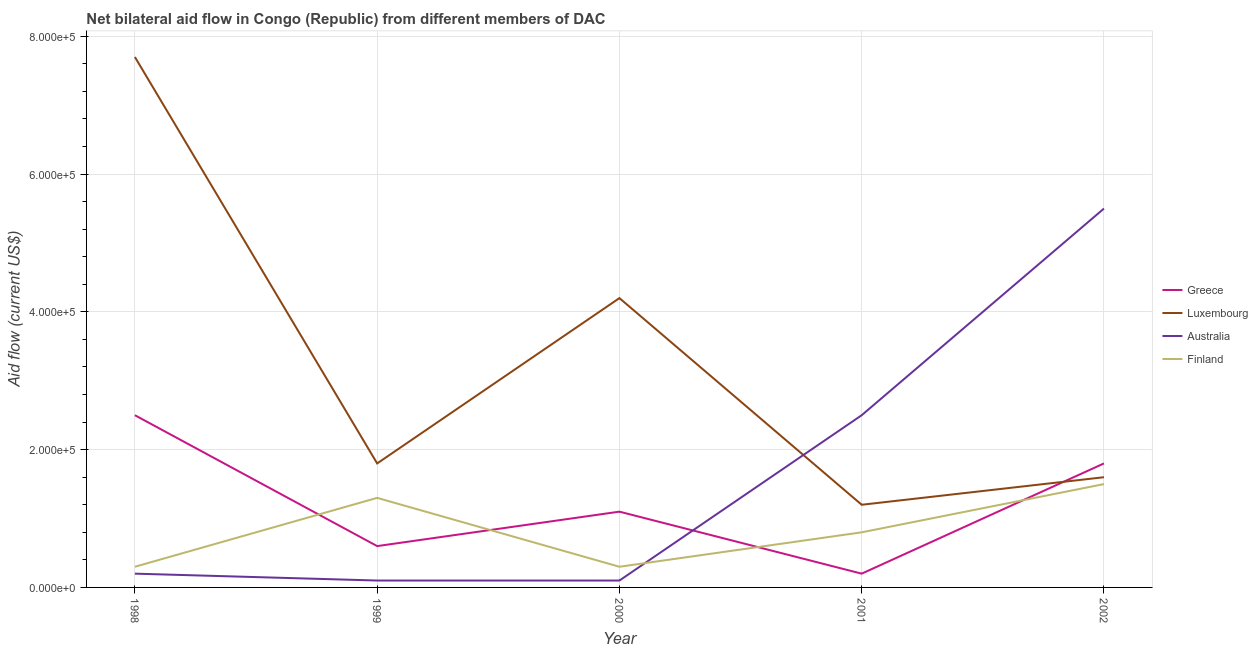Is the number of lines equal to the number of legend labels?
Ensure brevity in your answer.  Yes. What is the amount of aid given by australia in 2001?
Your answer should be compact. 2.50e+05. Across all years, what is the maximum amount of aid given by luxembourg?
Offer a very short reply. 7.70e+05. Across all years, what is the minimum amount of aid given by greece?
Provide a succinct answer. 2.00e+04. In which year was the amount of aid given by finland minimum?
Offer a very short reply. 1998. What is the total amount of aid given by luxembourg in the graph?
Keep it short and to the point. 1.65e+06. What is the difference between the amount of aid given by greece in 2000 and that in 2001?
Your response must be concise. 9.00e+04. What is the difference between the amount of aid given by luxembourg in 2001 and the amount of aid given by greece in 1999?
Offer a terse response. 6.00e+04. What is the average amount of aid given by australia per year?
Make the answer very short. 1.68e+05. In the year 2000, what is the difference between the amount of aid given by luxembourg and amount of aid given by australia?
Your answer should be compact. 4.10e+05. In how many years, is the amount of aid given by australia greater than 440000 US$?
Provide a succinct answer. 1. What is the ratio of the amount of aid given by australia in 1999 to that in 2001?
Your answer should be compact. 0.04. Is the amount of aid given by australia in 1999 less than that in 2002?
Your response must be concise. Yes. Is the difference between the amount of aid given by finland in 1999 and 2001 greater than the difference between the amount of aid given by luxembourg in 1999 and 2001?
Give a very brief answer. No. What is the difference between the highest and the second highest amount of aid given by luxembourg?
Your response must be concise. 3.50e+05. What is the difference between the highest and the lowest amount of aid given by australia?
Your response must be concise. 5.40e+05. In how many years, is the amount of aid given by australia greater than the average amount of aid given by australia taken over all years?
Keep it short and to the point. 2. Is it the case that in every year, the sum of the amount of aid given by greece and amount of aid given by luxembourg is greater than the amount of aid given by australia?
Keep it short and to the point. No. Does the amount of aid given by australia monotonically increase over the years?
Your response must be concise. No. Is the amount of aid given by greece strictly less than the amount of aid given by luxembourg over the years?
Ensure brevity in your answer.  No. What is the difference between two consecutive major ticks on the Y-axis?
Your answer should be compact. 2.00e+05. Does the graph contain any zero values?
Give a very brief answer. No. Does the graph contain grids?
Your answer should be compact. Yes. How are the legend labels stacked?
Ensure brevity in your answer.  Vertical. What is the title of the graph?
Offer a very short reply. Net bilateral aid flow in Congo (Republic) from different members of DAC. What is the label or title of the Y-axis?
Offer a terse response. Aid flow (current US$). What is the Aid flow (current US$) in Greece in 1998?
Your answer should be compact. 2.50e+05. What is the Aid flow (current US$) of Luxembourg in 1998?
Ensure brevity in your answer.  7.70e+05. What is the Aid flow (current US$) of Australia in 1998?
Provide a short and direct response. 2.00e+04. What is the Aid flow (current US$) of Finland in 1998?
Give a very brief answer. 3.00e+04. What is the Aid flow (current US$) of Greece in 1999?
Your response must be concise. 6.00e+04. What is the Aid flow (current US$) of Luxembourg in 1999?
Your response must be concise. 1.80e+05. What is the Aid flow (current US$) of Australia in 1999?
Offer a terse response. 10000. What is the Aid flow (current US$) of Greece in 2000?
Keep it short and to the point. 1.10e+05. What is the Aid flow (current US$) of Australia in 2000?
Your answer should be compact. 10000. What is the Aid flow (current US$) of Luxembourg in 2001?
Offer a terse response. 1.20e+05. What is the Aid flow (current US$) of Greece in 2002?
Make the answer very short. 1.80e+05. What is the Aid flow (current US$) of Luxembourg in 2002?
Provide a short and direct response. 1.60e+05. What is the Aid flow (current US$) of Australia in 2002?
Offer a terse response. 5.50e+05. What is the Aid flow (current US$) of Finland in 2002?
Your answer should be compact. 1.50e+05. Across all years, what is the maximum Aid flow (current US$) of Greece?
Your answer should be compact. 2.50e+05. Across all years, what is the maximum Aid flow (current US$) of Luxembourg?
Offer a terse response. 7.70e+05. Across all years, what is the maximum Aid flow (current US$) in Finland?
Make the answer very short. 1.50e+05. Across all years, what is the minimum Aid flow (current US$) of Greece?
Keep it short and to the point. 2.00e+04. Across all years, what is the minimum Aid flow (current US$) of Luxembourg?
Keep it short and to the point. 1.20e+05. What is the total Aid flow (current US$) of Greece in the graph?
Offer a very short reply. 6.20e+05. What is the total Aid flow (current US$) in Luxembourg in the graph?
Ensure brevity in your answer.  1.65e+06. What is the total Aid flow (current US$) in Australia in the graph?
Your answer should be very brief. 8.40e+05. What is the total Aid flow (current US$) of Finland in the graph?
Your answer should be very brief. 4.20e+05. What is the difference between the Aid flow (current US$) of Greece in 1998 and that in 1999?
Your answer should be compact. 1.90e+05. What is the difference between the Aid flow (current US$) of Luxembourg in 1998 and that in 1999?
Offer a terse response. 5.90e+05. What is the difference between the Aid flow (current US$) in Australia in 1998 and that in 1999?
Provide a short and direct response. 10000. What is the difference between the Aid flow (current US$) in Greece in 1998 and that in 2000?
Ensure brevity in your answer.  1.40e+05. What is the difference between the Aid flow (current US$) of Luxembourg in 1998 and that in 2000?
Provide a short and direct response. 3.50e+05. What is the difference between the Aid flow (current US$) in Australia in 1998 and that in 2000?
Make the answer very short. 10000. What is the difference between the Aid flow (current US$) of Greece in 1998 and that in 2001?
Ensure brevity in your answer.  2.30e+05. What is the difference between the Aid flow (current US$) of Luxembourg in 1998 and that in 2001?
Your answer should be very brief. 6.50e+05. What is the difference between the Aid flow (current US$) of Australia in 1998 and that in 2001?
Offer a terse response. -2.30e+05. What is the difference between the Aid flow (current US$) in Finland in 1998 and that in 2001?
Ensure brevity in your answer.  -5.00e+04. What is the difference between the Aid flow (current US$) in Luxembourg in 1998 and that in 2002?
Offer a terse response. 6.10e+05. What is the difference between the Aid flow (current US$) of Australia in 1998 and that in 2002?
Your answer should be very brief. -5.30e+05. What is the difference between the Aid flow (current US$) in Finland in 1998 and that in 2002?
Provide a short and direct response. -1.20e+05. What is the difference between the Aid flow (current US$) of Australia in 1999 and that in 2000?
Make the answer very short. 0. What is the difference between the Aid flow (current US$) in Australia in 1999 and that in 2001?
Make the answer very short. -2.40e+05. What is the difference between the Aid flow (current US$) of Finland in 1999 and that in 2001?
Your response must be concise. 5.00e+04. What is the difference between the Aid flow (current US$) in Australia in 1999 and that in 2002?
Your answer should be very brief. -5.40e+05. What is the difference between the Aid flow (current US$) in Finland in 1999 and that in 2002?
Your answer should be very brief. -2.00e+04. What is the difference between the Aid flow (current US$) of Finland in 2000 and that in 2001?
Your answer should be very brief. -5.00e+04. What is the difference between the Aid flow (current US$) of Greece in 2000 and that in 2002?
Give a very brief answer. -7.00e+04. What is the difference between the Aid flow (current US$) of Australia in 2000 and that in 2002?
Keep it short and to the point. -5.40e+05. What is the difference between the Aid flow (current US$) in Finland in 2000 and that in 2002?
Keep it short and to the point. -1.20e+05. What is the difference between the Aid flow (current US$) of Greece in 1998 and the Aid flow (current US$) of Finland in 1999?
Offer a terse response. 1.20e+05. What is the difference between the Aid flow (current US$) of Luxembourg in 1998 and the Aid flow (current US$) of Australia in 1999?
Your response must be concise. 7.60e+05. What is the difference between the Aid flow (current US$) in Luxembourg in 1998 and the Aid flow (current US$) in Finland in 1999?
Give a very brief answer. 6.40e+05. What is the difference between the Aid flow (current US$) of Greece in 1998 and the Aid flow (current US$) of Finland in 2000?
Make the answer very short. 2.20e+05. What is the difference between the Aid flow (current US$) of Luxembourg in 1998 and the Aid flow (current US$) of Australia in 2000?
Offer a very short reply. 7.60e+05. What is the difference between the Aid flow (current US$) of Luxembourg in 1998 and the Aid flow (current US$) of Finland in 2000?
Keep it short and to the point. 7.40e+05. What is the difference between the Aid flow (current US$) in Greece in 1998 and the Aid flow (current US$) in Finland in 2001?
Your answer should be compact. 1.70e+05. What is the difference between the Aid flow (current US$) of Luxembourg in 1998 and the Aid flow (current US$) of Australia in 2001?
Make the answer very short. 5.20e+05. What is the difference between the Aid flow (current US$) in Luxembourg in 1998 and the Aid flow (current US$) in Finland in 2001?
Provide a succinct answer. 6.90e+05. What is the difference between the Aid flow (current US$) of Greece in 1998 and the Aid flow (current US$) of Luxembourg in 2002?
Make the answer very short. 9.00e+04. What is the difference between the Aid flow (current US$) in Luxembourg in 1998 and the Aid flow (current US$) in Finland in 2002?
Provide a succinct answer. 6.20e+05. What is the difference between the Aid flow (current US$) of Greece in 1999 and the Aid flow (current US$) of Luxembourg in 2000?
Your response must be concise. -3.60e+05. What is the difference between the Aid flow (current US$) in Greece in 1999 and the Aid flow (current US$) in Australia in 2000?
Provide a short and direct response. 5.00e+04. What is the difference between the Aid flow (current US$) in Greece in 1999 and the Aid flow (current US$) in Finland in 2000?
Your response must be concise. 3.00e+04. What is the difference between the Aid flow (current US$) in Luxembourg in 1999 and the Aid flow (current US$) in Australia in 2000?
Ensure brevity in your answer.  1.70e+05. What is the difference between the Aid flow (current US$) of Greece in 1999 and the Aid flow (current US$) of Luxembourg in 2001?
Provide a short and direct response. -6.00e+04. What is the difference between the Aid flow (current US$) of Greece in 1999 and the Aid flow (current US$) of Australia in 2001?
Your response must be concise. -1.90e+05. What is the difference between the Aid flow (current US$) in Luxembourg in 1999 and the Aid flow (current US$) in Finland in 2001?
Provide a succinct answer. 1.00e+05. What is the difference between the Aid flow (current US$) in Australia in 1999 and the Aid flow (current US$) in Finland in 2001?
Make the answer very short. -7.00e+04. What is the difference between the Aid flow (current US$) in Greece in 1999 and the Aid flow (current US$) in Luxembourg in 2002?
Ensure brevity in your answer.  -1.00e+05. What is the difference between the Aid flow (current US$) in Greece in 1999 and the Aid flow (current US$) in Australia in 2002?
Provide a short and direct response. -4.90e+05. What is the difference between the Aid flow (current US$) of Greece in 1999 and the Aid flow (current US$) of Finland in 2002?
Your answer should be very brief. -9.00e+04. What is the difference between the Aid flow (current US$) of Luxembourg in 1999 and the Aid flow (current US$) of Australia in 2002?
Ensure brevity in your answer.  -3.70e+05. What is the difference between the Aid flow (current US$) in Luxembourg in 1999 and the Aid flow (current US$) in Finland in 2002?
Your answer should be very brief. 3.00e+04. What is the difference between the Aid flow (current US$) of Greece in 2000 and the Aid flow (current US$) of Australia in 2001?
Provide a short and direct response. -1.40e+05. What is the difference between the Aid flow (current US$) in Luxembourg in 2000 and the Aid flow (current US$) in Australia in 2001?
Keep it short and to the point. 1.70e+05. What is the difference between the Aid flow (current US$) of Luxembourg in 2000 and the Aid flow (current US$) of Finland in 2001?
Your response must be concise. 3.40e+05. What is the difference between the Aid flow (current US$) of Australia in 2000 and the Aid flow (current US$) of Finland in 2001?
Make the answer very short. -7.00e+04. What is the difference between the Aid flow (current US$) in Greece in 2000 and the Aid flow (current US$) in Luxembourg in 2002?
Ensure brevity in your answer.  -5.00e+04. What is the difference between the Aid flow (current US$) of Greece in 2000 and the Aid flow (current US$) of Australia in 2002?
Give a very brief answer. -4.40e+05. What is the difference between the Aid flow (current US$) in Greece in 2000 and the Aid flow (current US$) in Finland in 2002?
Give a very brief answer. -4.00e+04. What is the difference between the Aid flow (current US$) in Luxembourg in 2000 and the Aid flow (current US$) in Australia in 2002?
Provide a short and direct response. -1.30e+05. What is the difference between the Aid flow (current US$) of Luxembourg in 2000 and the Aid flow (current US$) of Finland in 2002?
Offer a terse response. 2.70e+05. What is the difference between the Aid flow (current US$) in Greece in 2001 and the Aid flow (current US$) in Australia in 2002?
Ensure brevity in your answer.  -5.30e+05. What is the difference between the Aid flow (current US$) of Luxembourg in 2001 and the Aid flow (current US$) of Australia in 2002?
Offer a terse response. -4.30e+05. What is the average Aid flow (current US$) in Greece per year?
Provide a succinct answer. 1.24e+05. What is the average Aid flow (current US$) in Luxembourg per year?
Provide a succinct answer. 3.30e+05. What is the average Aid flow (current US$) of Australia per year?
Your answer should be compact. 1.68e+05. What is the average Aid flow (current US$) in Finland per year?
Give a very brief answer. 8.40e+04. In the year 1998, what is the difference between the Aid flow (current US$) of Greece and Aid flow (current US$) of Luxembourg?
Make the answer very short. -5.20e+05. In the year 1998, what is the difference between the Aid flow (current US$) of Greece and Aid flow (current US$) of Australia?
Keep it short and to the point. 2.30e+05. In the year 1998, what is the difference between the Aid flow (current US$) in Luxembourg and Aid flow (current US$) in Australia?
Make the answer very short. 7.50e+05. In the year 1998, what is the difference between the Aid flow (current US$) in Luxembourg and Aid flow (current US$) in Finland?
Your response must be concise. 7.40e+05. In the year 1999, what is the difference between the Aid flow (current US$) of Greece and Aid flow (current US$) of Australia?
Keep it short and to the point. 5.00e+04. In the year 1999, what is the difference between the Aid flow (current US$) in Luxembourg and Aid flow (current US$) in Australia?
Your answer should be compact. 1.70e+05. In the year 1999, what is the difference between the Aid flow (current US$) of Australia and Aid flow (current US$) of Finland?
Your response must be concise. -1.20e+05. In the year 2000, what is the difference between the Aid flow (current US$) in Greece and Aid flow (current US$) in Luxembourg?
Give a very brief answer. -3.10e+05. In the year 2000, what is the difference between the Aid flow (current US$) in Greece and Aid flow (current US$) in Australia?
Ensure brevity in your answer.  1.00e+05. In the year 2000, what is the difference between the Aid flow (current US$) in Greece and Aid flow (current US$) in Finland?
Give a very brief answer. 8.00e+04. In the year 2000, what is the difference between the Aid flow (current US$) of Luxembourg and Aid flow (current US$) of Finland?
Ensure brevity in your answer.  3.90e+05. In the year 2000, what is the difference between the Aid flow (current US$) of Australia and Aid flow (current US$) of Finland?
Your response must be concise. -2.00e+04. In the year 2001, what is the difference between the Aid flow (current US$) in Greece and Aid flow (current US$) in Finland?
Ensure brevity in your answer.  -6.00e+04. In the year 2001, what is the difference between the Aid flow (current US$) in Luxembourg and Aid flow (current US$) in Australia?
Offer a terse response. -1.30e+05. In the year 2001, what is the difference between the Aid flow (current US$) of Luxembourg and Aid flow (current US$) of Finland?
Offer a terse response. 4.00e+04. In the year 2002, what is the difference between the Aid flow (current US$) in Greece and Aid flow (current US$) in Luxembourg?
Offer a terse response. 2.00e+04. In the year 2002, what is the difference between the Aid flow (current US$) of Greece and Aid flow (current US$) of Australia?
Your answer should be very brief. -3.70e+05. In the year 2002, what is the difference between the Aid flow (current US$) in Greece and Aid flow (current US$) in Finland?
Offer a very short reply. 3.00e+04. In the year 2002, what is the difference between the Aid flow (current US$) in Luxembourg and Aid flow (current US$) in Australia?
Keep it short and to the point. -3.90e+05. In the year 2002, what is the difference between the Aid flow (current US$) of Luxembourg and Aid flow (current US$) of Finland?
Ensure brevity in your answer.  10000. What is the ratio of the Aid flow (current US$) in Greece in 1998 to that in 1999?
Your response must be concise. 4.17. What is the ratio of the Aid flow (current US$) in Luxembourg in 1998 to that in 1999?
Make the answer very short. 4.28. What is the ratio of the Aid flow (current US$) in Finland in 1998 to that in 1999?
Make the answer very short. 0.23. What is the ratio of the Aid flow (current US$) of Greece in 1998 to that in 2000?
Provide a short and direct response. 2.27. What is the ratio of the Aid flow (current US$) of Luxembourg in 1998 to that in 2000?
Provide a short and direct response. 1.83. What is the ratio of the Aid flow (current US$) of Australia in 1998 to that in 2000?
Offer a terse response. 2. What is the ratio of the Aid flow (current US$) in Finland in 1998 to that in 2000?
Provide a succinct answer. 1. What is the ratio of the Aid flow (current US$) of Greece in 1998 to that in 2001?
Provide a short and direct response. 12.5. What is the ratio of the Aid flow (current US$) in Luxembourg in 1998 to that in 2001?
Provide a succinct answer. 6.42. What is the ratio of the Aid flow (current US$) of Greece in 1998 to that in 2002?
Your response must be concise. 1.39. What is the ratio of the Aid flow (current US$) in Luxembourg in 1998 to that in 2002?
Give a very brief answer. 4.81. What is the ratio of the Aid flow (current US$) in Australia in 1998 to that in 2002?
Ensure brevity in your answer.  0.04. What is the ratio of the Aid flow (current US$) in Greece in 1999 to that in 2000?
Give a very brief answer. 0.55. What is the ratio of the Aid flow (current US$) of Luxembourg in 1999 to that in 2000?
Ensure brevity in your answer.  0.43. What is the ratio of the Aid flow (current US$) in Australia in 1999 to that in 2000?
Your answer should be compact. 1. What is the ratio of the Aid flow (current US$) in Finland in 1999 to that in 2000?
Offer a terse response. 4.33. What is the ratio of the Aid flow (current US$) of Greece in 1999 to that in 2001?
Your answer should be very brief. 3. What is the ratio of the Aid flow (current US$) of Australia in 1999 to that in 2001?
Your response must be concise. 0.04. What is the ratio of the Aid flow (current US$) of Finland in 1999 to that in 2001?
Make the answer very short. 1.62. What is the ratio of the Aid flow (current US$) of Greece in 1999 to that in 2002?
Offer a terse response. 0.33. What is the ratio of the Aid flow (current US$) in Australia in 1999 to that in 2002?
Give a very brief answer. 0.02. What is the ratio of the Aid flow (current US$) of Finland in 1999 to that in 2002?
Keep it short and to the point. 0.87. What is the ratio of the Aid flow (current US$) in Luxembourg in 2000 to that in 2001?
Give a very brief answer. 3.5. What is the ratio of the Aid flow (current US$) in Greece in 2000 to that in 2002?
Provide a succinct answer. 0.61. What is the ratio of the Aid flow (current US$) of Luxembourg in 2000 to that in 2002?
Your answer should be compact. 2.62. What is the ratio of the Aid flow (current US$) of Australia in 2000 to that in 2002?
Give a very brief answer. 0.02. What is the ratio of the Aid flow (current US$) of Finland in 2000 to that in 2002?
Keep it short and to the point. 0.2. What is the ratio of the Aid flow (current US$) of Luxembourg in 2001 to that in 2002?
Offer a terse response. 0.75. What is the ratio of the Aid flow (current US$) of Australia in 2001 to that in 2002?
Offer a very short reply. 0.45. What is the ratio of the Aid flow (current US$) of Finland in 2001 to that in 2002?
Provide a succinct answer. 0.53. What is the difference between the highest and the second highest Aid flow (current US$) of Luxembourg?
Your answer should be compact. 3.50e+05. What is the difference between the highest and the second highest Aid flow (current US$) in Australia?
Keep it short and to the point. 3.00e+05. What is the difference between the highest and the lowest Aid flow (current US$) in Greece?
Your answer should be very brief. 2.30e+05. What is the difference between the highest and the lowest Aid flow (current US$) of Luxembourg?
Give a very brief answer. 6.50e+05. What is the difference between the highest and the lowest Aid flow (current US$) in Australia?
Keep it short and to the point. 5.40e+05. What is the difference between the highest and the lowest Aid flow (current US$) in Finland?
Make the answer very short. 1.20e+05. 